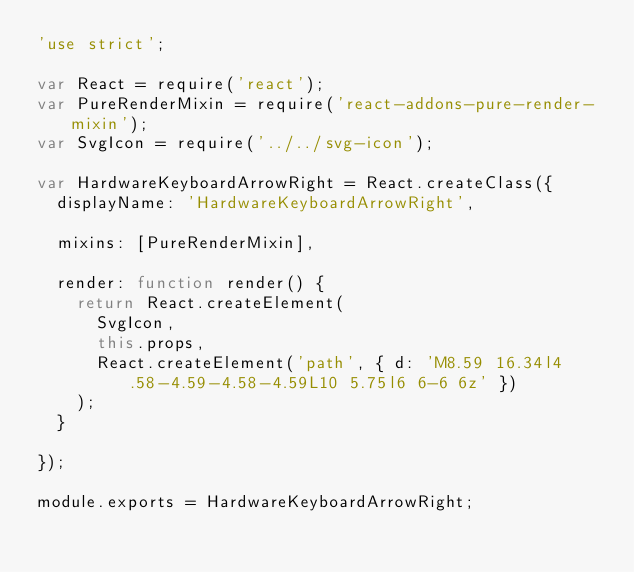Convert code to text. <code><loc_0><loc_0><loc_500><loc_500><_JavaScript_>'use strict';

var React = require('react');
var PureRenderMixin = require('react-addons-pure-render-mixin');
var SvgIcon = require('../../svg-icon');

var HardwareKeyboardArrowRight = React.createClass({
  displayName: 'HardwareKeyboardArrowRight',

  mixins: [PureRenderMixin],

  render: function render() {
    return React.createElement(
      SvgIcon,
      this.props,
      React.createElement('path', { d: 'M8.59 16.34l4.58-4.59-4.58-4.59L10 5.75l6 6-6 6z' })
    );
  }

});

module.exports = HardwareKeyboardArrowRight;</code> 